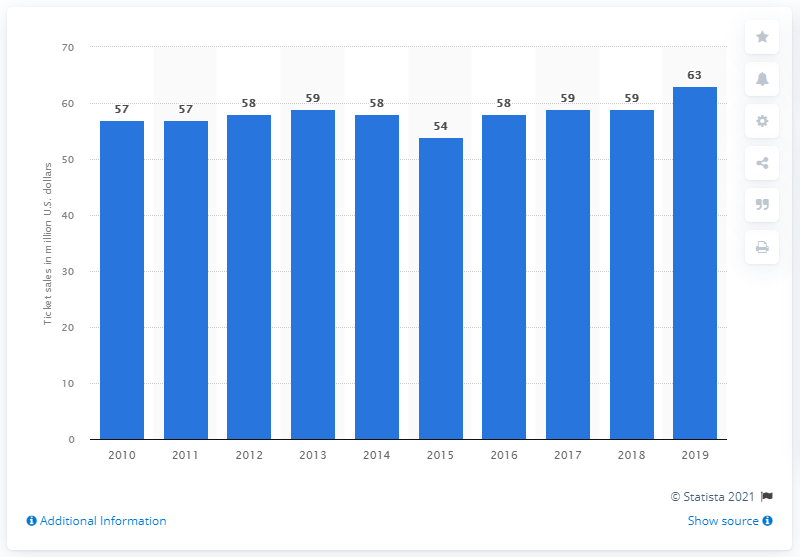Specify some key components in this picture. The Indianapolis Colts generated approximately $63 million in gate receipts in 2019. 